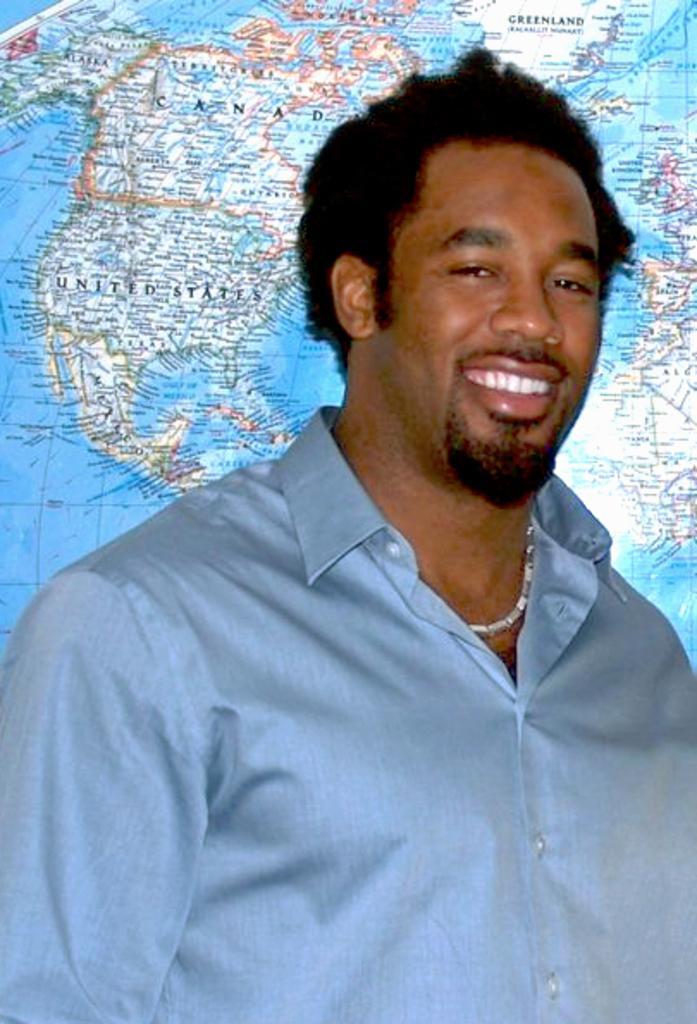In one or two sentences, can you explain what this image depicts? In the center of the image, we can see a man wearing a chain and smiling. In the background, there is a globe. 